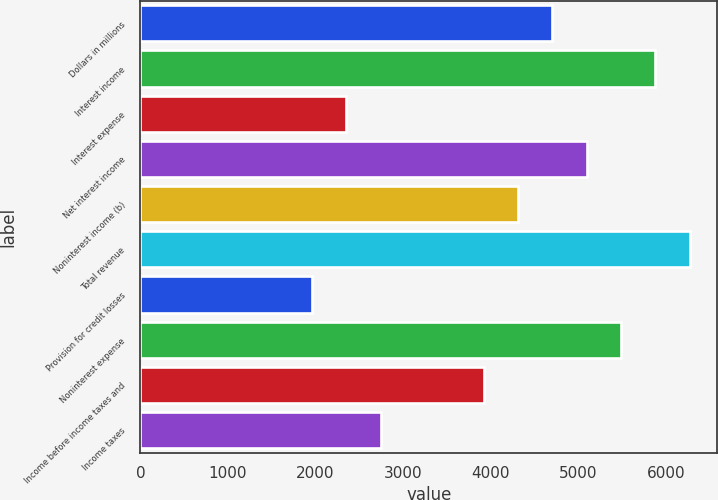Convert chart. <chart><loc_0><loc_0><loc_500><loc_500><bar_chart><fcel>Dollars in millions<fcel>Interest income<fcel>Interest expense<fcel>Net interest income<fcel>Noninterest income (b)<fcel>Total revenue<fcel>Provision for credit losses<fcel>Noninterest expense<fcel>Income before income taxes and<fcel>Income taxes<nl><fcel>4703.63<fcel>5879.09<fcel>2352.71<fcel>5095.45<fcel>4311.81<fcel>6270.91<fcel>1960.89<fcel>5487.27<fcel>3919.99<fcel>2744.53<nl></chart> 